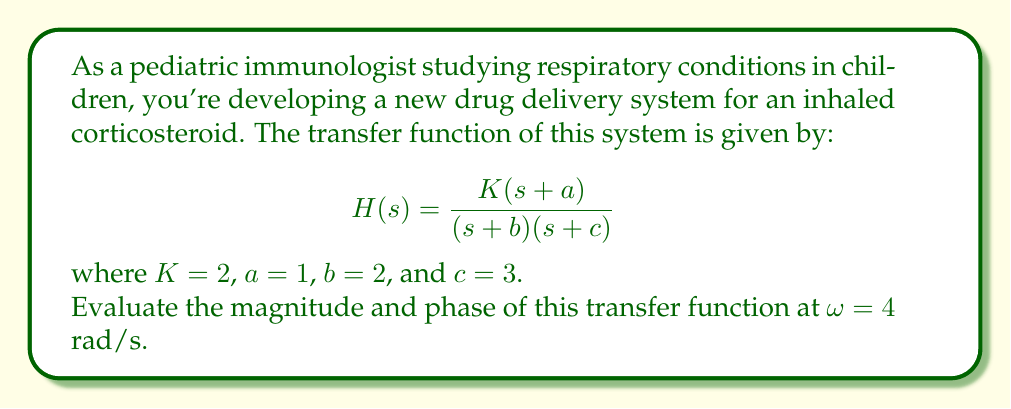Give your solution to this math problem. To evaluate the transfer function at $\omega = 4$ rad/s, we need to substitute $s = j\omega = j4$ into $H(s)$ and calculate its magnitude and phase.

1) Substituting $s = j4$ into $H(s)$:

   $$H(j4) = \frac{2(j4+1)}{(j4+2)(j4+3)}$$

2) Simplify the numerator and denominator:

   Numerator: $2(j4+1) = 2(1+j4) = 2+j8$
   Denominator: $(j4+2)(j4+3) = (2+j4)(3+j4) = 6+j12-16+j12 = -10+j24$

   $$H(j4) = \frac{2+j8}{-10+j24}$$

3) To find the magnitude, we use $|H(j4)| = \frac{|2+j8|}{|-10+j24|}$:

   $|2+j8| = \sqrt{2^2 + 8^2} = \sqrt{68}$
   $|-10+j24| = \sqrt{(-10)^2 + 24^2} = \sqrt{676} = 26$

   $$|H(j4)| = \frac{\sqrt{68}}{26} \approx 0.3168$$

4) To find the phase, we use $\angle H(j4) = \angle(2+j8) - \angle(-10+j24)$:

   $\angle(2+j8) = \arctan(\frac{8}{2}) = \arctan(4) \approx 1.3258$ rad
   $\angle(-10+j24) = \arctan(\frac{24}{-10}) + \pi = -1.1760 + \pi = 1.9656$ rad

   $$\angle H(j4) = 1.3258 - 1.9656 = -0.6398$$ rad

Therefore, at $\omega = 4$ rad/s:
Magnitude $|H(j4)| \approx 0.3168$
Phase $\angle H(j4) \approx -0.6398$ rad
Answer: At $\omega = 4$ rad/s:
Magnitude: $|H(j4)| \approx 0.3168$
Phase: $\angle H(j4) \approx -0.6398$ rad 